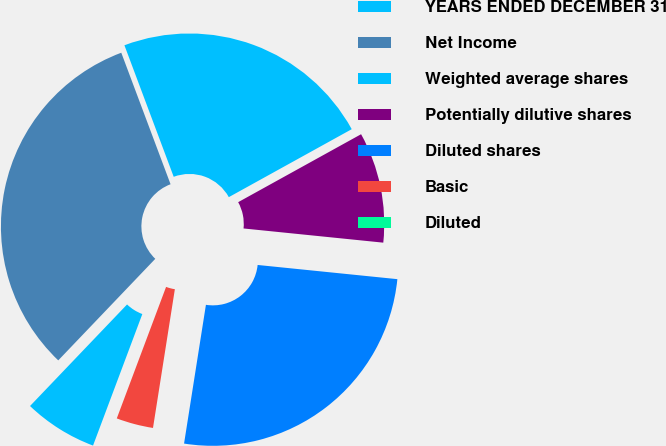Convert chart to OTSL. <chart><loc_0><loc_0><loc_500><loc_500><pie_chart><fcel>YEARS ENDED DECEMBER 31<fcel>Net Income<fcel>Weighted average shares<fcel>Potentially dilutive shares<fcel>Diluted shares<fcel>Basic<fcel>Diluted<nl><fcel>6.43%<fcel>32.16%<fcel>22.67%<fcel>9.65%<fcel>25.88%<fcel>3.22%<fcel>0.0%<nl></chart> 